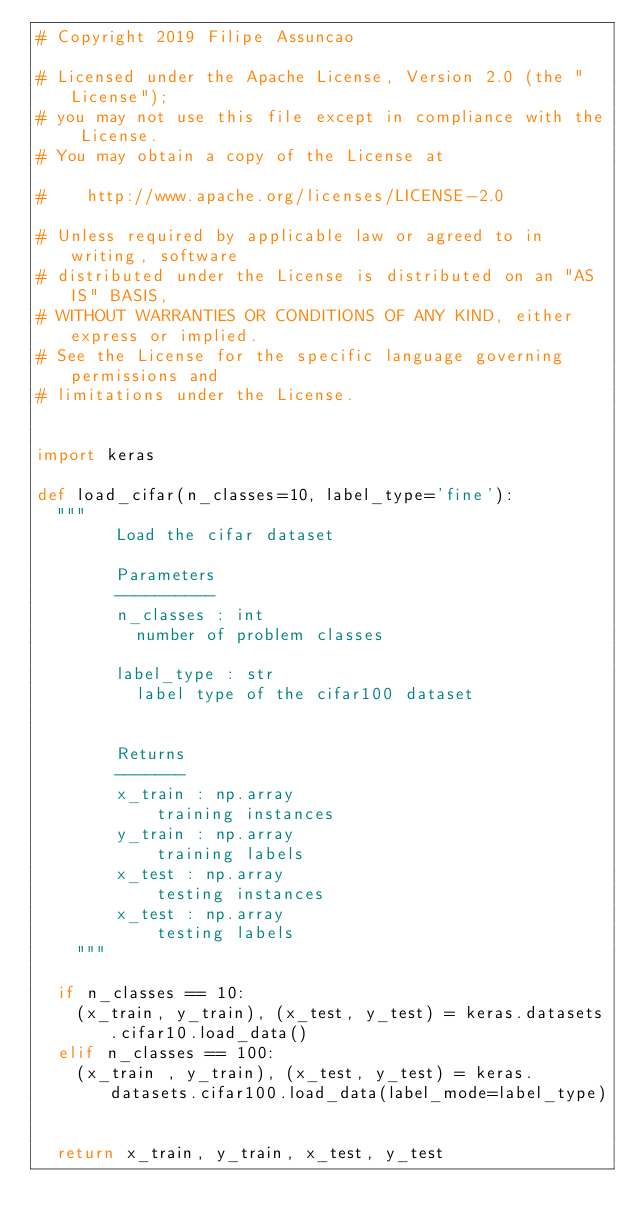<code> <loc_0><loc_0><loc_500><loc_500><_Python_># Copyright 2019 Filipe Assuncao

# Licensed under the Apache License, Version 2.0 (the "License");
# you may not use this file except in compliance with the License.
# You may obtain a copy of the License at

#    http://www.apache.org/licenses/LICENSE-2.0

# Unless required by applicable law or agreed to in writing, software
# distributed under the License is distributed on an "AS IS" BASIS,
# WITHOUT WARRANTIES OR CONDITIONS OF ANY KIND, either express or implied.
# See the License for the specific language governing permissions and
# limitations under the License.


import keras

def load_cifar(n_classes=10, label_type='fine'):
	"""
        Load the cifar dataset

        Parameters
        ----------
        n_classes : int
        	number of problem classes

        label_type : str
        	label type of the cifar100 dataset


        Returns
        -------
        x_train : np.array
            training instances
        y_train : np.array
            training labels 
        x_test : np.array
            testing instances
        x_test : np.array
            testing labels
    """

	if n_classes == 10:
		(x_train, y_train), (x_test, y_test) = keras.datasets.cifar10.load_data()
	elif n_classes == 100:
		(x_train , y_train), (x_test, y_test) = keras.datasets.cifar100.load_data(label_mode=label_type)


	return x_train, y_train, x_test, y_test


</code> 